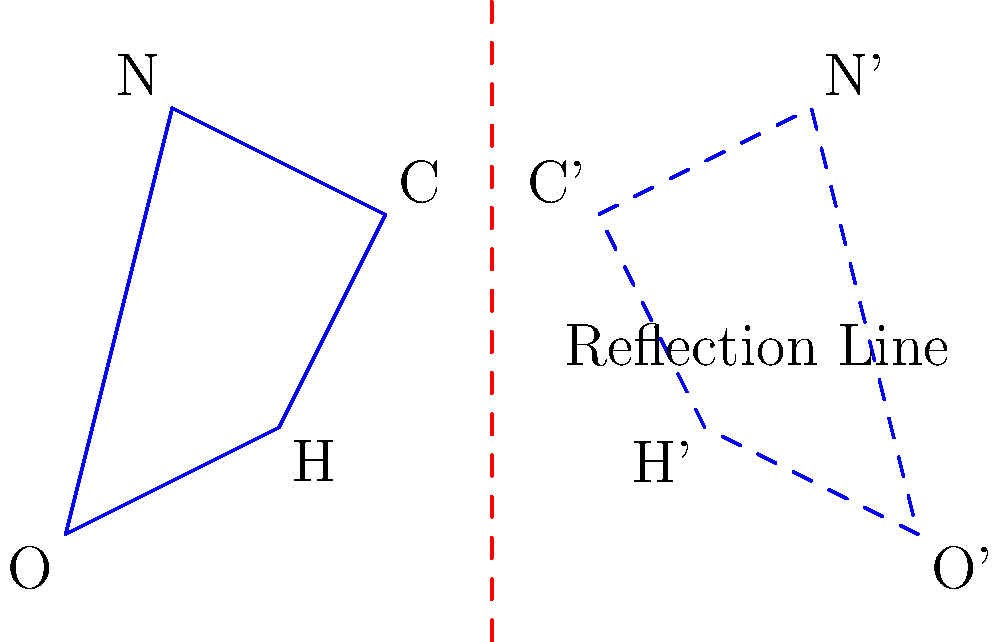Consider the simplified molecular structure of a complex herb compound shown in the diagram. The structure is represented by the solid blue quadrilateral OHCN. If this structure is reflected across the red dashed line, what will be the coordinates of point C' (the reflection of point C) to the nearest whole number? To find the coordinates of point C' after reflection, we need to follow these steps:

1. Identify the original coordinates of point C:
   From the diagram, we can estimate that C is approximately at (3, 3).

2. Determine the equation of the reflection line:
   The reflection line appears to be vertical and passes through x = 4.
   Its equation is x = 4.

3. Apply the reflection formula:
   For a vertical reflection line x = a, the reflection of a point (x, y) is (2a - x, y).
   In this case, a = 4.

4. Calculate the coordinates of C':
   x' = 2(4) - 3 = 8 - 3 = 5
   y' = 3 (y-coordinate remains unchanged)

5. Round to the nearest whole number:
   (5, 3)

Therefore, the coordinates of C' after reflection are approximately (5, 3).
Answer: (5, 3) 